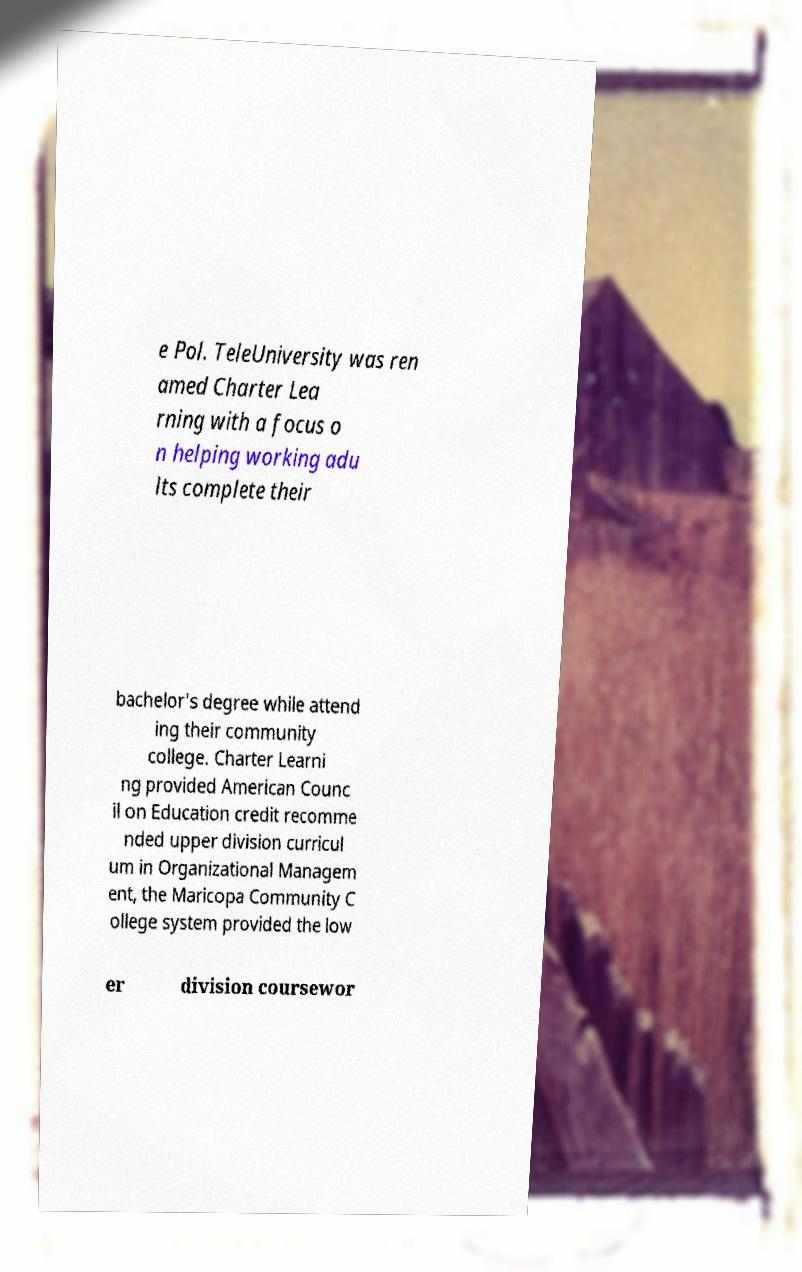For documentation purposes, I need the text within this image transcribed. Could you provide that? e Pol. TeleUniversity was ren amed Charter Lea rning with a focus o n helping working adu lts complete their bachelor's degree while attend ing their community college. Charter Learni ng provided American Counc il on Education credit recomme nded upper division curricul um in Organizational Managem ent, the Maricopa Community C ollege system provided the low er division coursewor 